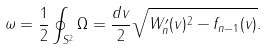Convert formula to latex. <formula><loc_0><loc_0><loc_500><loc_500>\omega = \frac { 1 } { 2 } \oint _ { S ^ { 2 } } \Omega = \frac { d v } { 2 } \sqrt { W ^ { \prime } _ { n } ( v ) ^ { 2 } - f _ { n - 1 } ( v ) } .</formula> 